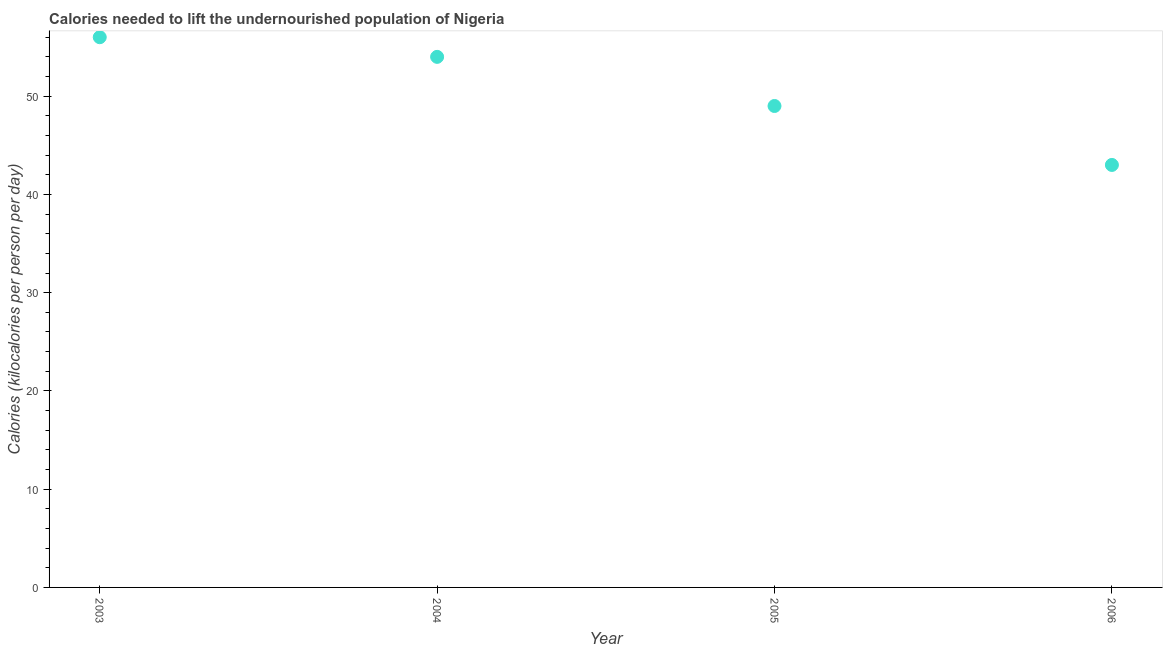What is the depth of food deficit in 2006?
Give a very brief answer. 43. Across all years, what is the maximum depth of food deficit?
Provide a short and direct response. 56. Across all years, what is the minimum depth of food deficit?
Offer a very short reply. 43. In which year was the depth of food deficit maximum?
Your answer should be compact. 2003. In which year was the depth of food deficit minimum?
Provide a short and direct response. 2006. What is the sum of the depth of food deficit?
Your answer should be very brief. 202. What is the difference between the depth of food deficit in 2004 and 2005?
Ensure brevity in your answer.  5. What is the average depth of food deficit per year?
Offer a terse response. 50.5. What is the median depth of food deficit?
Your response must be concise. 51.5. In how many years, is the depth of food deficit greater than 22 kilocalories?
Keep it short and to the point. 4. What is the ratio of the depth of food deficit in 2003 to that in 2006?
Offer a terse response. 1.3. Is the difference between the depth of food deficit in 2005 and 2006 greater than the difference between any two years?
Offer a very short reply. No. What is the difference between the highest and the second highest depth of food deficit?
Your response must be concise. 2. Is the sum of the depth of food deficit in 2004 and 2006 greater than the maximum depth of food deficit across all years?
Offer a terse response. Yes. What is the difference between the highest and the lowest depth of food deficit?
Your response must be concise. 13. Does the depth of food deficit monotonically increase over the years?
Your answer should be compact. No. How many years are there in the graph?
Offer a terse response. 4. Are the values on the major ticks of Y-axis written in scientific E-notation?
Make the answer very short. No. Does the graph contain any zero values?
Give a very brief answer. No. Does the graph contain grids?
Provide a succinct answer. No. What is the title of the graph?
Provide a short and direct response. Calories needed to lift the undernourished population of Nigeria. What is the label or title of the X-axis?
Make the answer very short. Year. What is the label or title of the Y-axis?
Make the answer very short. Calories (kilocalories per person per day). What is the Calories (kilocalories per person per day) in 2003?
Your answer should be compact. 56. What is the Calories (kilocalories per person per day) in 2004?
Make the answer very short. 54. What is the Calories (kilocalories per person per day) in 2006?
Your answer should be very brief. 43. What is the difference between the Calories (kilocalories per person per day) in 2003 and 2004?
Your answer should be compact. 2. What is the difference between the Calories (kilocalories per person per day) in 2004 and 2006?
Provide a short and direct response. 11. What is the difference between the Calories (kilocalories per person per day) in 2005 and 2006?
Ensure brevity in your answer.  6. What is the ratio of the Calories (kilocalories per person per day) in 2003 to that in 2004?
Provide a succinct answer. 1.04. What is the ratio of the Calories (kilocalories per person per day) in 2003 to that in 2005?
Your answer should be very brief. 1.14. What is the ratio of the Calories (kilocalories per person per day) in 2003 to that in 2006?
Provide a succinct answer. 1.3. What is the ratio of the Calories (kilocalories per person per day) in 2004 to that in 2005?
Provide a succinct answer. 1.1. What is the ratio of the Calories (kilocalories per person per day) in 2004 to that in 2006?
Offer a very short reply. 1.26. What is the ratio of the Calories (kilocalories per person per day) in 2005 to that in 2006?
Offer a terse response. 1.14. 